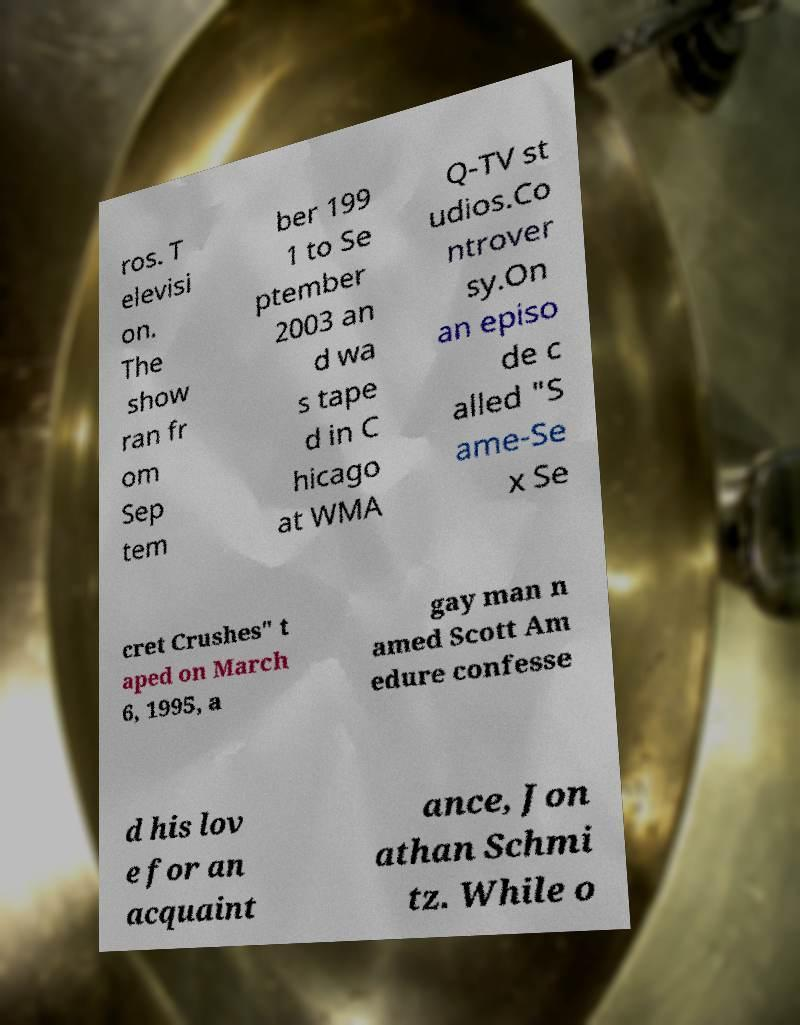For documentation purposes, I need the text within this image transcribed. Could you provide that? ros. T elevisi on. The show ran fr om Sep tem ber 199 1 to Se ptember 2003 an d wa s tape d in C hicago at WMA Q-TV st udios.Co ntrover sy.On an episo de c alled "S ame-Se x Se cret Crushes" t aped on March 6, 1995, a gay man n amed Scott Am edure confesse d his lov e for an acquaint ance, Jon athan Schmi tz. While o 